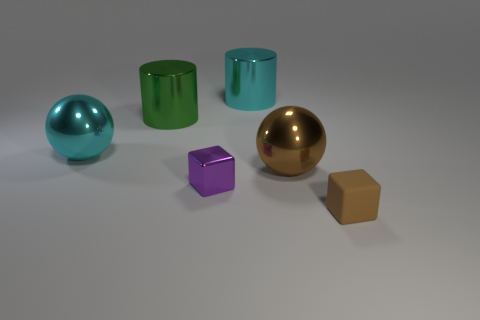Add 3 yellow metallic spheres. How many objects exist? 9 Add 5 cyan objects. How many cyan objects exist? 7 Subtract all cyan cylinders. How many cylinders are left? 1 Subtract 0 gray balls. How many objects are left? 6 Subtract all blocks. How many objects are left? 4 Subtract 1 blocks. How many blocks are left? 1 Subtract all purple cylinders. Subtract all cyan blocks. How many cylinders are left? 2 Subtract all gray cubes. How many brown balls are left? 1 Subtract all blue spheres. Subtract all large metallic cylinders. How many objects are left? 4 Add 1 big cyan metal objects. How many big cyan metal objects are left? 3 